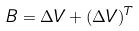<formula> <loc_0><loc_0><loc_500><loc_500>B = \Delta V + ( \Delta V ) ^ { T }</formula> 